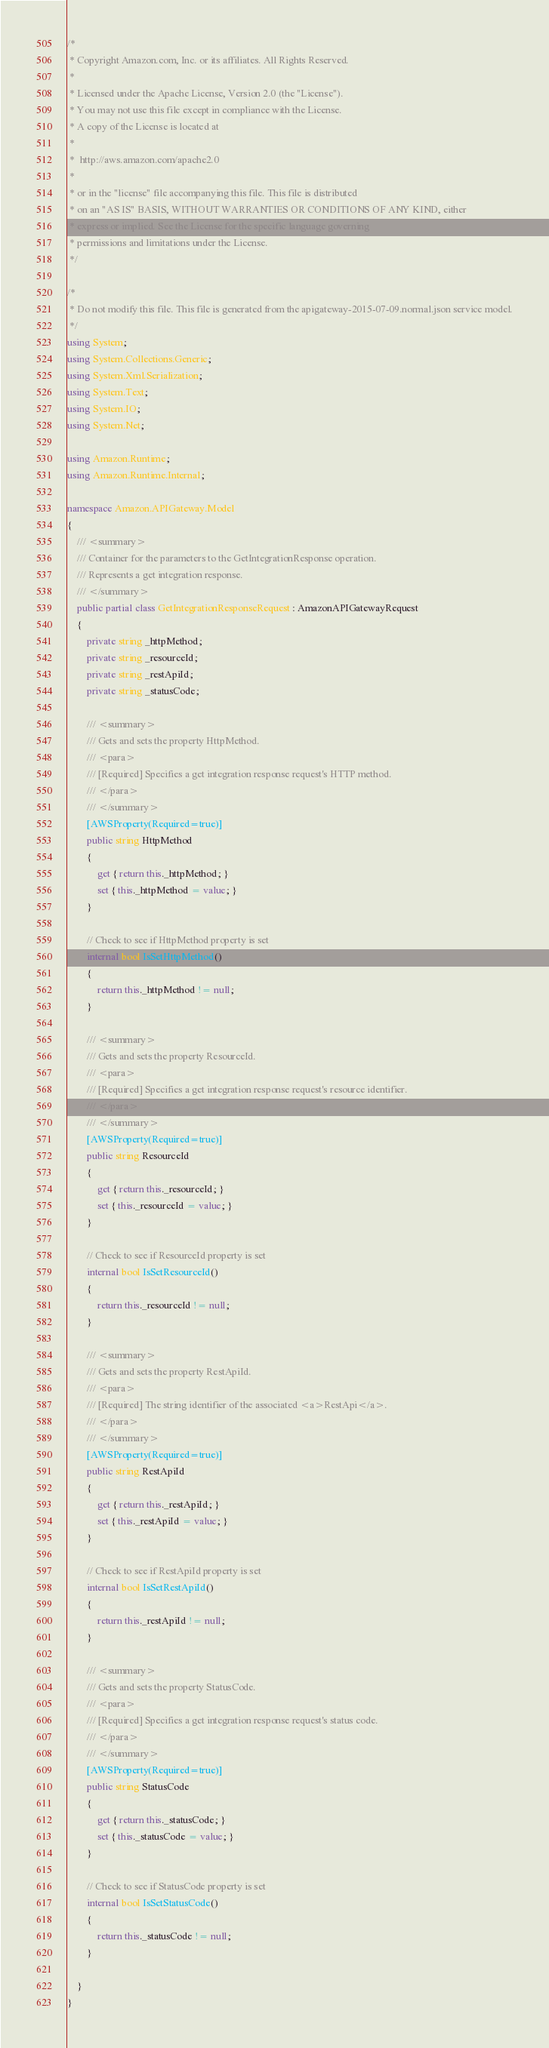<code> <loc_0><loc_0><loc_500><loc_500><_C#_>/*
 * Copyright Amazon.com, Inc. or its affiliates. All Rights Reserved.
 * 
 * Licensed under the Apache License, Version 2.0 (the "License").
 * You may not use this file except in compliance with the License.
 * A copy of the License is located at
 * 
 *  http://aws.amazon.com/apache2.0
 * 
 * or in the "license" file accompanying this file. This file is distributed
 * on an "AS IS" BASIS, WITHOUT WARRANTIES OR CONDITIONS OF ANY KIND, either
 * express or implied. See the License for the specific language governing
 * permissions and limitations under the License.
 */

/*
 * Do not modify this file. This file is generated from the apigateway-2015-07-09.normal.json service model.
 */
using System;
using System.Collections.Generic;
using System.Xml.Serialization;
using System.Text;
using System.IO;
using System.Net;

using Amazon.Runtime;
using Amazon.Runtime.Internal;

namespace Amazon.APIGateway.Model
{
    /// <summary>
    /// Container for the parameters to the GetIntegrationResponse operation.
    /// Represents a get integration response.
    /// </summary>
    public partial class GetIntegrationResponseRequest : AmazonAPIGatewayRequest
    {
        private string _httpMethod;
        private string _resourceId;
        private string _restApiId;
        private string _statusCode;

        /// <summary>
        /// Gets and sets the property HttpMethod. 
        /// <para>
        /// [Required] Specifies a get integration response request's HTTP method.
        /// </para>
        /// </summary>
        [AWSProperty(Required=true)]
        public string HttpMethod
        {
            get { return this._httpMethod; }
            set { this._httpMethod = value; }
        }

        // Check to see if HttpMethod property is set
        internal bool IsSetHttpMethod()
        {
            return this._httpMethod != null;
        }

        /// <summary>
        /// Gets and sets the property ResourceId. 
        /// <para>
        /// [Required] Specifies a get integration response request's resource identifier.
        /// </para>
        /// </summary>
        [AWSProperty(Required=true)]
        public string ResourceId
        {
            get { return this._resourceId; }
            set { this._resourceId = value; }
        }

        // Check to see if ResourceId property is set
        internal bool IsSetResourceId()
        {
            return this._resourceId != null;
        }

        /// <summary>
        /// Gets and sets the property RestApiId. 
        /// <para>
        /// [Required] The string identifier of the associated <a>RestApi</a>.
        /// </para>
        /// </summary>
        [AWSProperty(Required=true)]
        public string RestApiId
        {
            get { return this._restApiId; }
            set { this._restApiId = value; }
        }

        // Check to see if RestApiId property is set
        internal bool IsSetRestApiId()
        {
            return this._restApiId != null;
        }

        /// <summary>
        /// Gets and sets the property StatusCode. 
        /// <para>
        /// [Required] Specifies a get integration response request's status code.
        /// </para>
        /// </summary>
        [AWSProperty(Required=true)]
        public string StatusCode
        {
            get { return this._statusCode; }
            set { this._statusCode = value; }
        }

        // Check to see if StatusCode property is set
        internal bool IsSetStatusCode()
        {
            return this._statusCode != null;
        }

    }
}</code> 